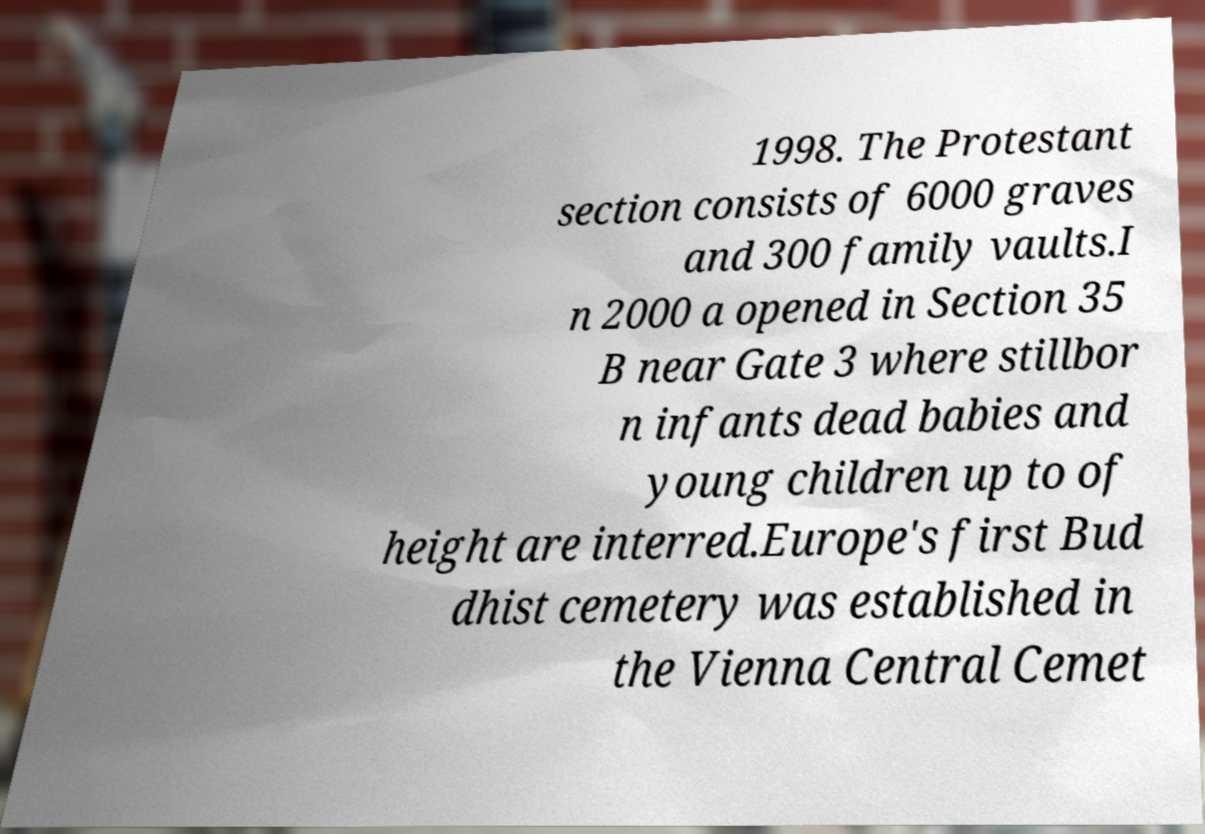I need the written content from this picture converted into text. Can you do that? 1998. The Protestant section consists of 6000 graves and 300 family vaults.I n 2000 a opened in Section 35 B near Gate 3 where stillbor n infants dead babies and young children up to of height are interred.Europe's first Bud dhist cemetery was established in the Vienna Central Cemet 